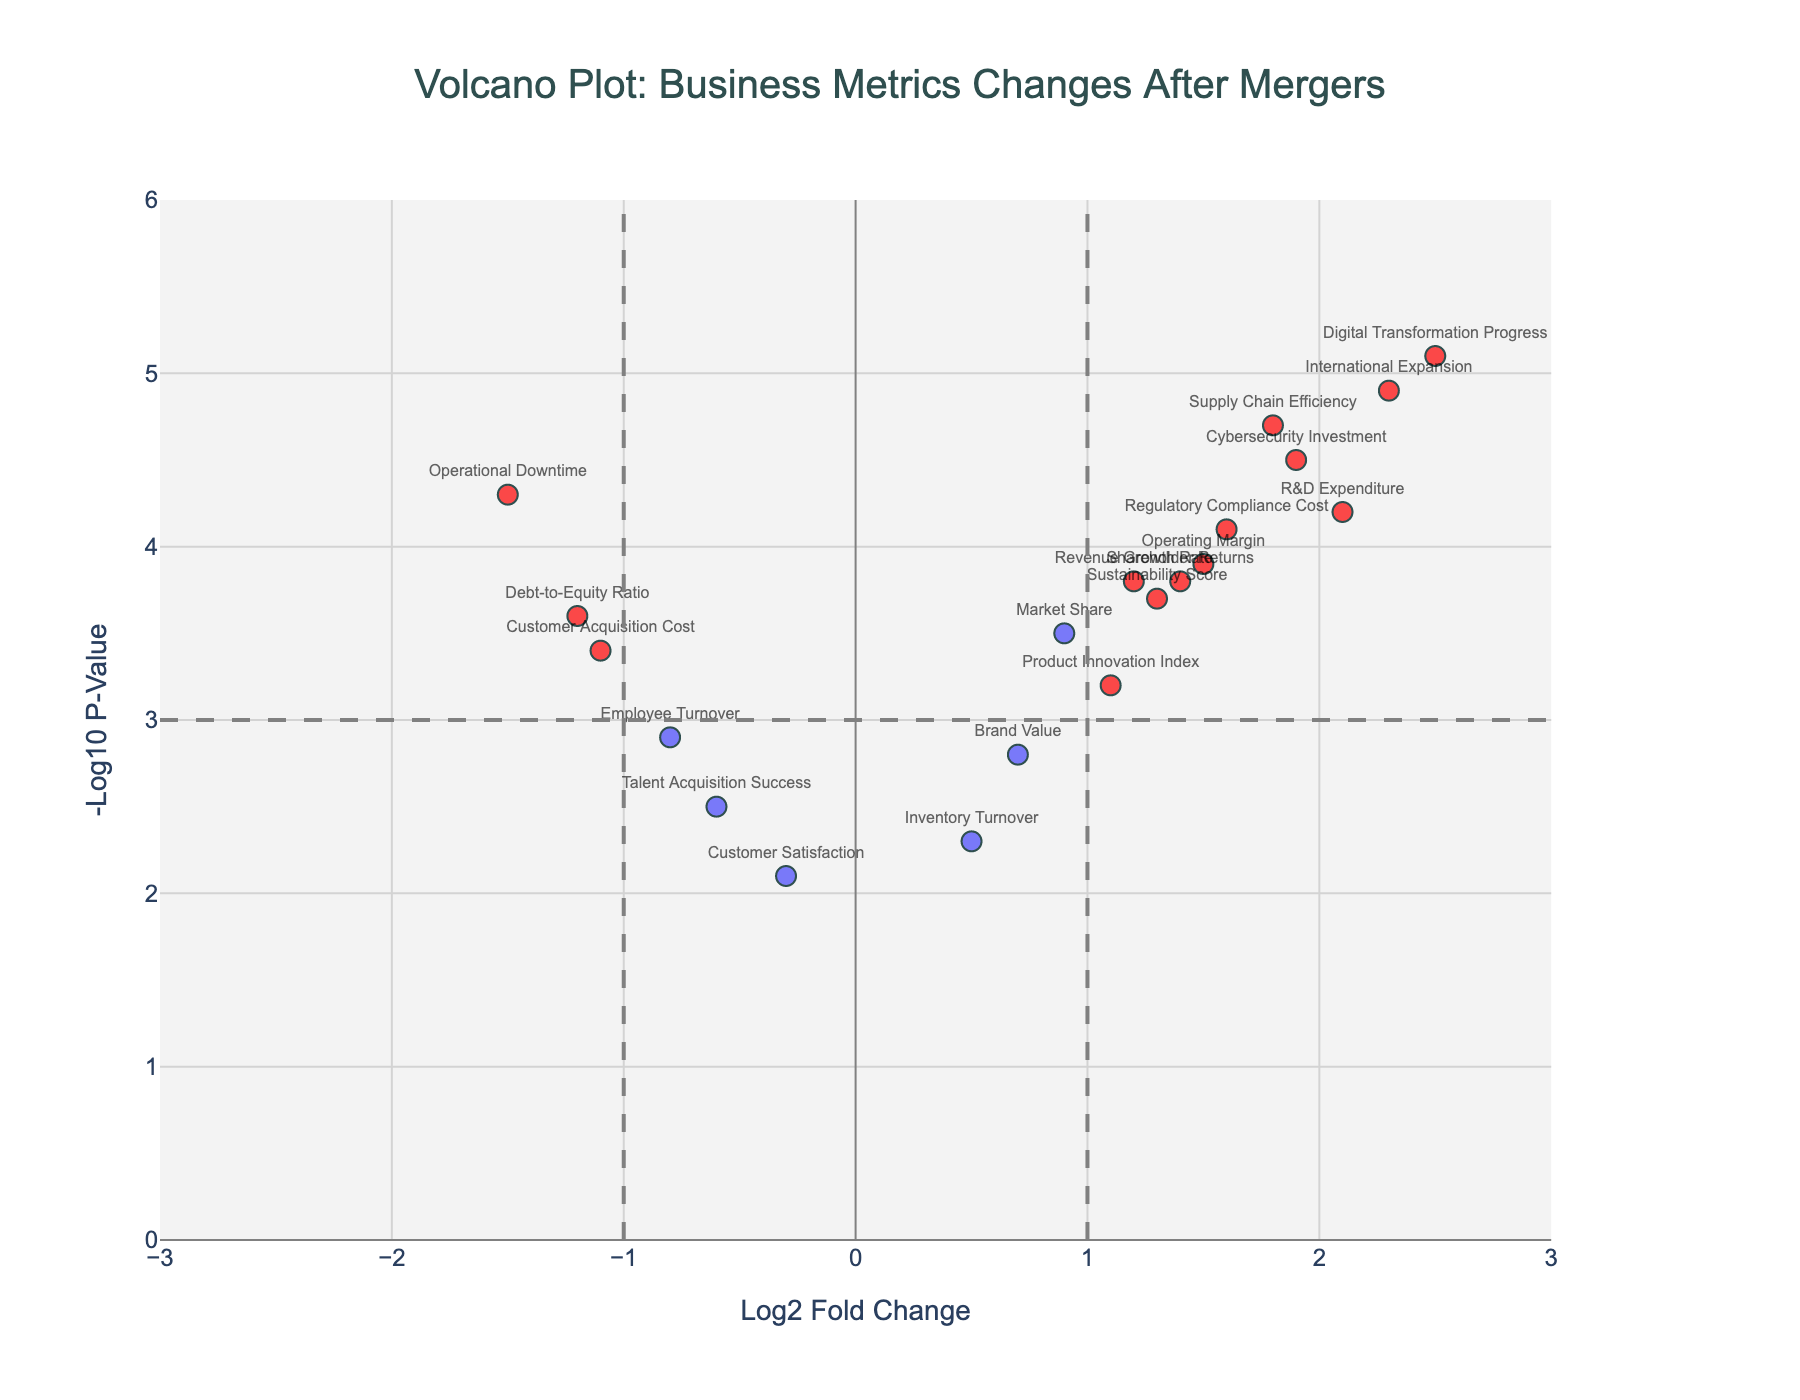How many data points are plotted in the figure? There are 19 companies listed in the data set, corresponding to 19 data points in the figure.
Answer: 19 What is the title of the figure? The title is located at the top of the figure and reads "Volcano Plot: Business Metrics Changes After Mergers".
Answer: Volcano Plot: Business Metrics Changes After Mergers Which company shows the highest Log2 Fold Change? By looking at the x-axis, the point farthest to the right represents "Digital Transformation Progress" with a Log2FoldChange of 2.5.
Answer: Digital Transformation Progress Which company reflects the lowest -Log10 P-Value among significant changes? The points with red color are considered significant. The company at the lowest point among the red dots is "Revenue Growth Rate" with a -Log10 P-Value of 3.8.
Answer: Revenue Growth Rate What is the range of the x-axis and y-axis? The x-axis ranges from -3 to 3, and the y-axis ranges from 0 to 6.
Answer: x-axis: -3 to 3, y-axis: 0 to 6 Is "Supply Chain Efficiency" considered significant, and why? A point is considered significant if its Log2 Fold Change is greater than 1 (or less than -1) and its -Log10 P-Value is greater than 3. "Supply Chain Efficiency" has Log2FoldChange of 1.8 and -Log10 P-Value of 4.7, meeting both criteria.
Answer: Yes Between "R&D Expenditure" and "Operating Margin", which metric shows a higher statistical significance? Statistical significance is represented by the -Log10 P-Value. Comparing values, "R&D Expenditure" has 4.2 while "Operating Margin" has 3.9.
Answer: R&D Expenditure What is the average Log2 Fold Change for the companies significantly impacted by the merger? The significantly impacted companies are marked in red. Their Log2FoldChange values are 1.2, 2.1, 1.5, 1.8, 2.3, 1.6, 2.5, 1.3, 1.9, 1.4. Adding these up gives 17.6, and dividing by 10 gives an average of 1.76.
Answer: 1.76 What is the difference in significance between "International Expansion" and "Customer Acquisition Cost"? "International Expansion" has a -Log10 P-Value of 4.9 and "Customer Acquisition Cost" has 3.4. The difference is 4.9 - 3.4 = 1.5.
Answer: 1.5 How many companies have a negative Log2 Fold Change? Companies with negative Log2 Fold Changes: Employee Turnover, Debt-to-Equity Ratio, Talent Acquisition Success, Customer Acquisition Cost, Operational Downtime. Counting these gives 5.
Answer: 5 